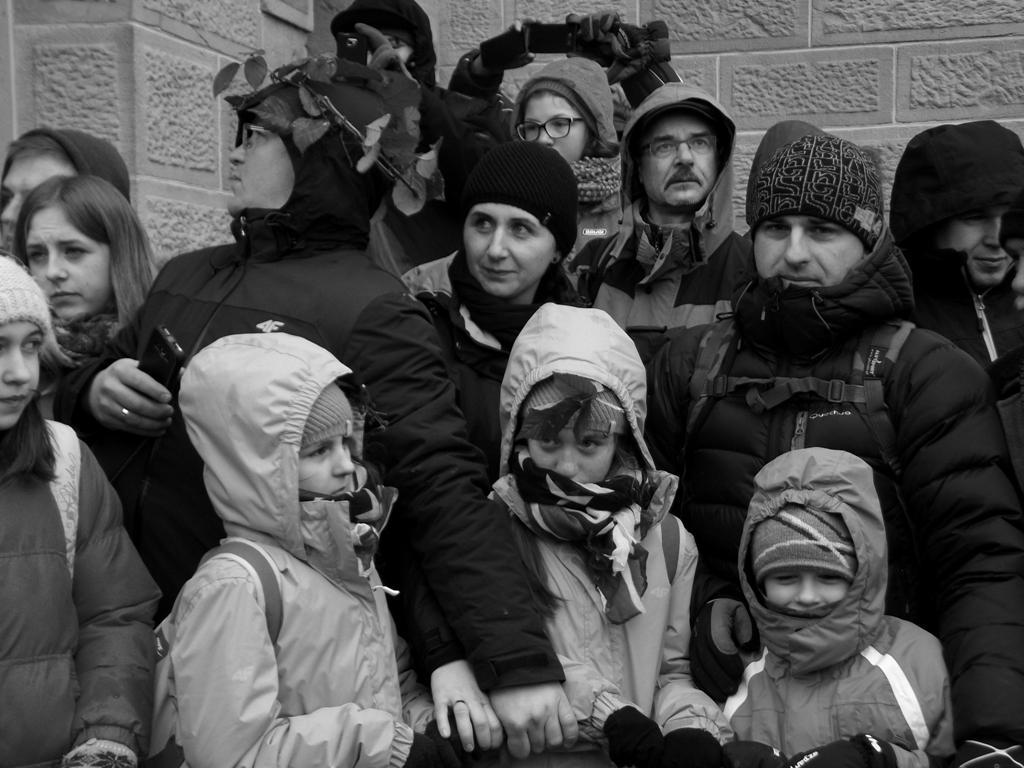Describe this image in one or two sentences. In this image we can see a group of people standing in front of the wall, a person is holding a cellphone and few of them are holding a rope. 